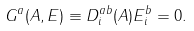<formula> <loc_0><loc_0><loc_500><loc_500>G ^ { a } ( { A } , { E } ) \equiv D ^ { a b } _ { i } ( { A } ) E ^ { b } _ { i } = 0 .</formula> 